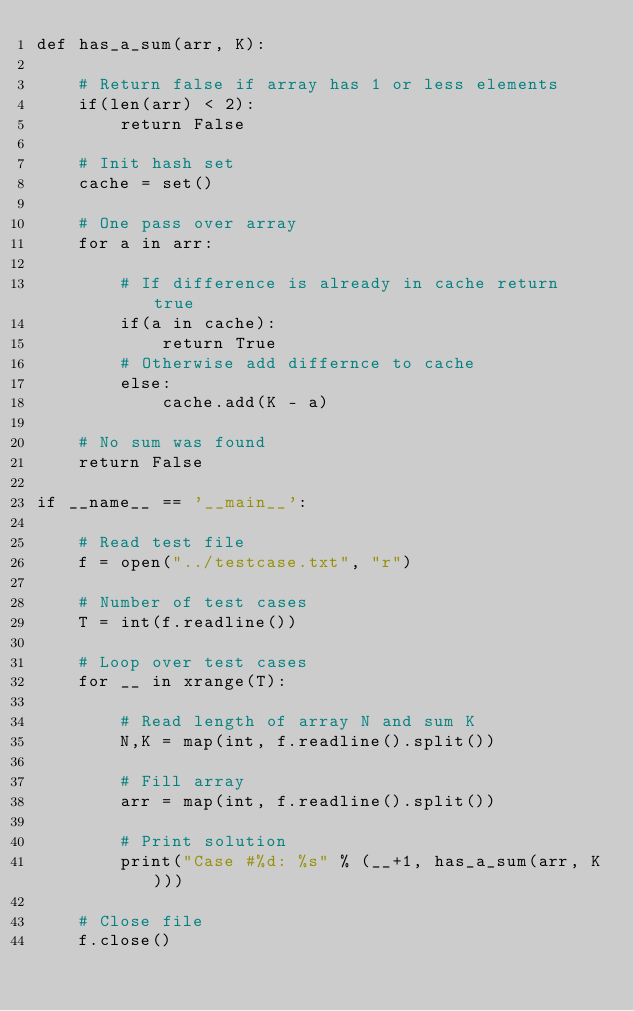Convert code to text. <code><loc_0><loc_0><loc_500><loc_500><_Python_>def has_a_sum(arr, K):

	# Return false if array has 1 or less elements
	if(len(arr) < 2):
		return False

	# Init hash set
	cache = set()

	# One pass over array
	for a in arr:

		# If difference is already in cache return true
		if(a in cache):
			return True
		# Otherwise add differnce to cache
		else:
			cache.add(K - a)

	# No sum was found
	return False

if __name__ == '__main__':
	
	# Read test file
	f = open("../testcase.txt", "r")

	# Number of test cases
	T = int(f.readline())

	# Loop over test cases
	for __ in xrange(T):

		# Read length of array N and sum K
		N,K = map(int, f.readline().split())

		# Fill array
		arr = map(int, f.readline().split())

		# Print solution
		print("Case #%d: %s" % (__+1, has_a_sum(arr, K)))

	# Close file
	f.close()</code> 